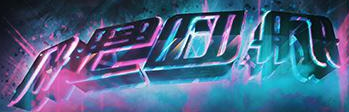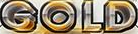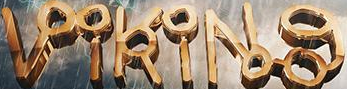What text is displayed in these images sequentially, separated by a semicolon? neon; GOLD; VikiNg 